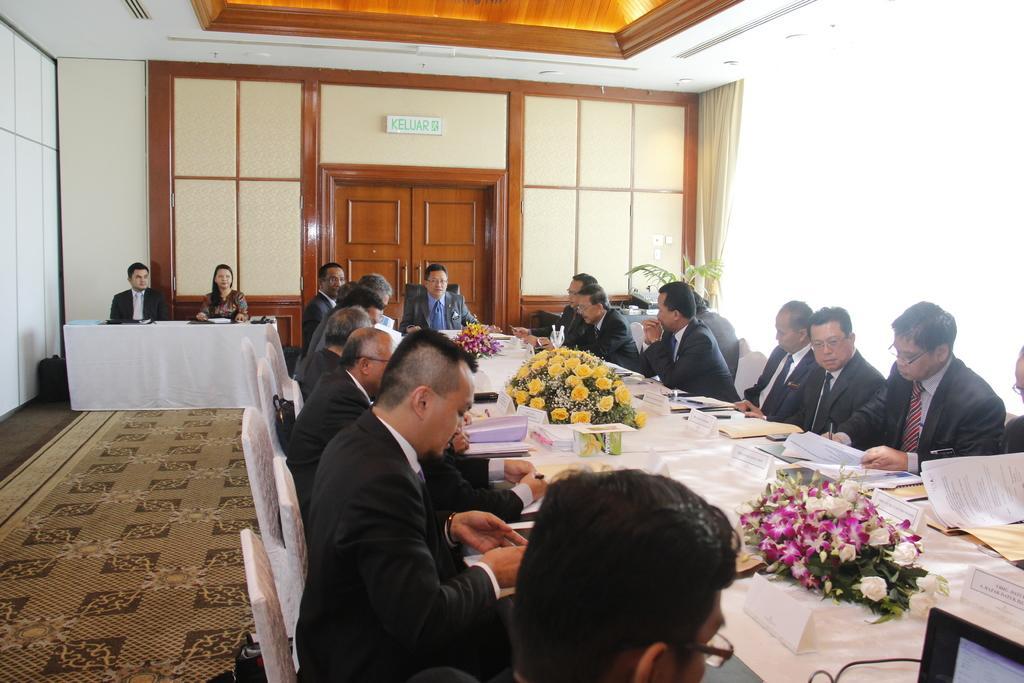Could you give a brief overview of what you see in this image? As we can see in the image there is a white color wall, door, few people sitting on chairs and there is a table. On table there are papers, books and bouquets. 